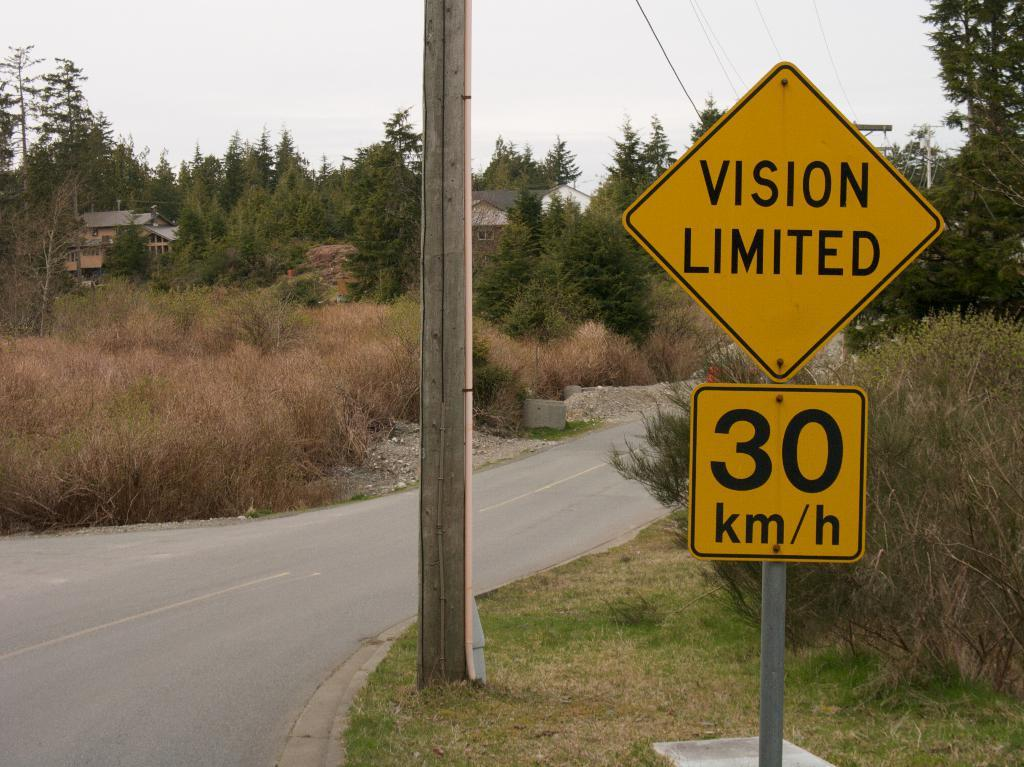Provide a one-sentence caption for the provided image. A sign warns drivers they may have trouble seeing on this road. 